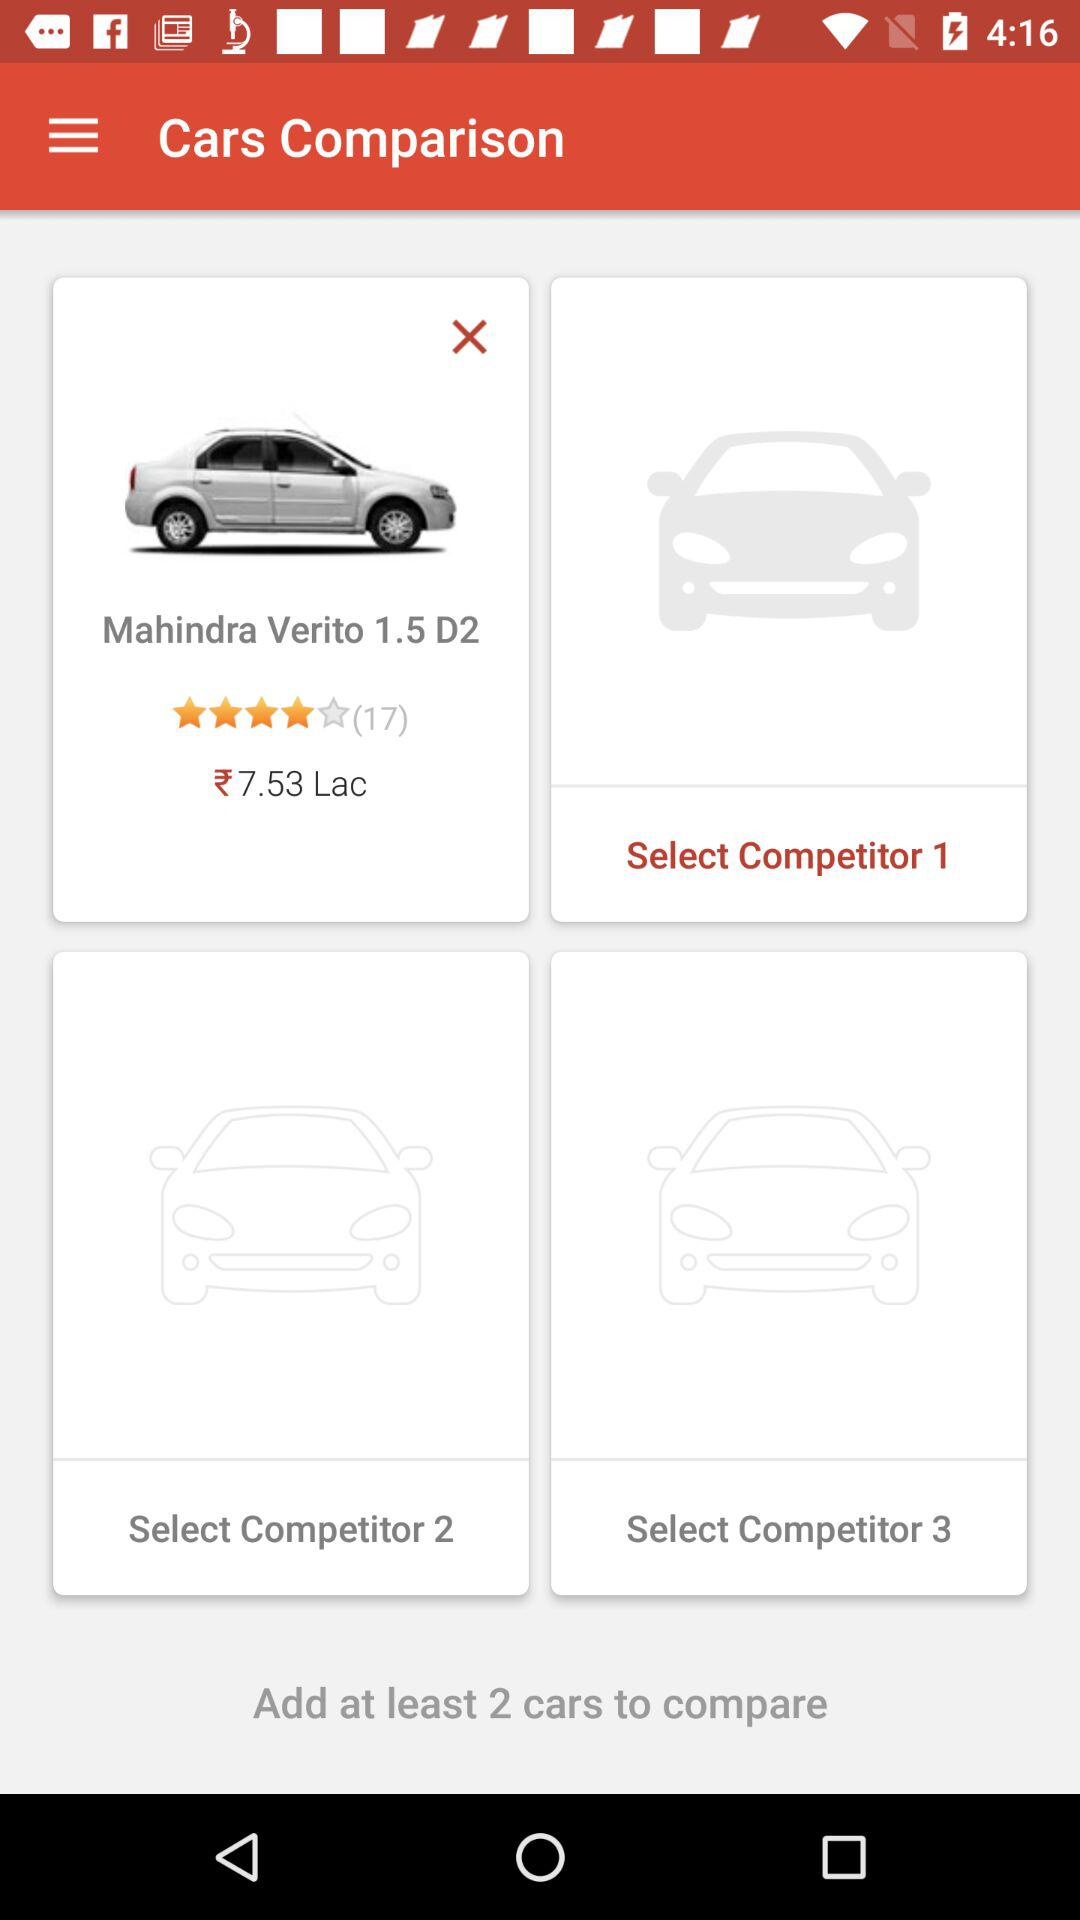How many people rated the Mahindra Verito? The Mahindra Verito is rated by 17 people. 